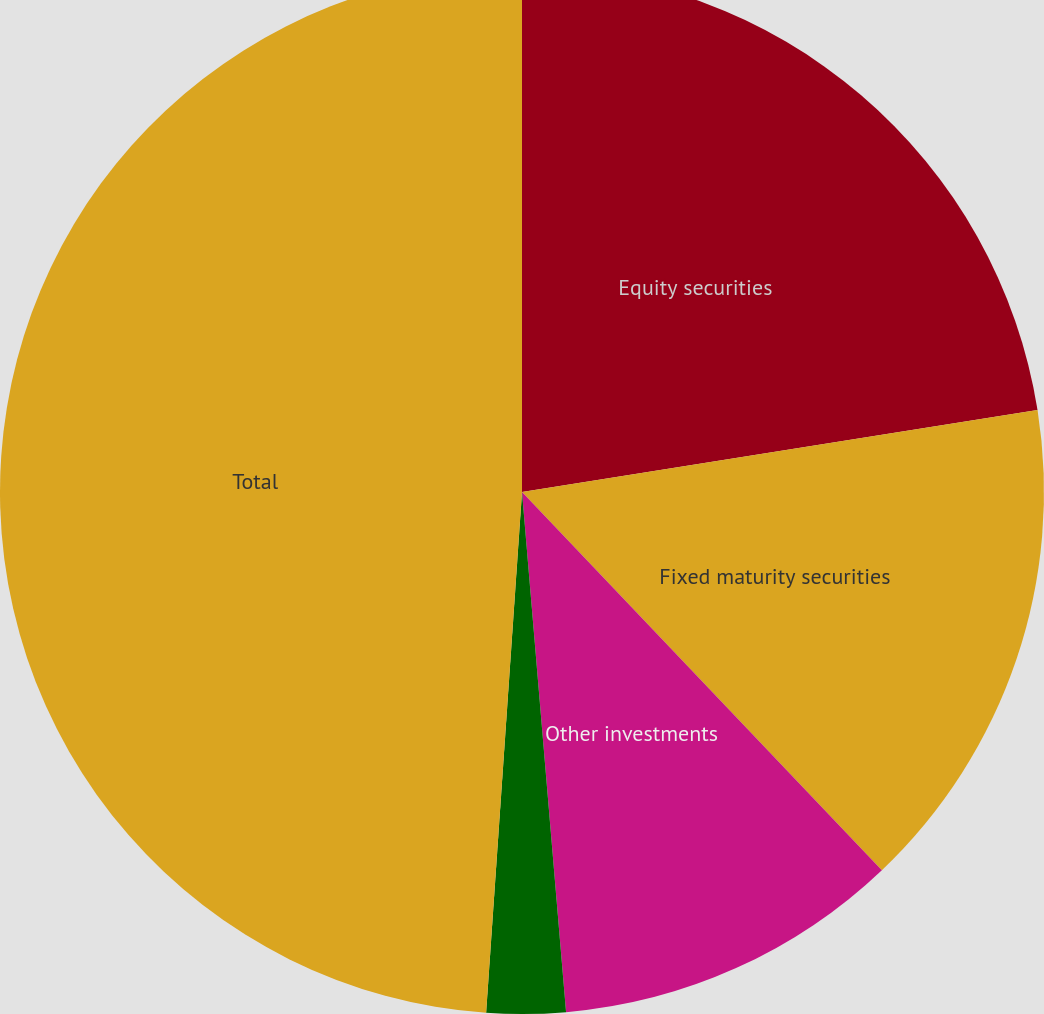<chart> <loc_0><loc_0><loc_500><loc_500><pie_chart><fcel>Equity securities<fcel>Fixed maturity securities<fcel>Other investments<fcel>Cash and cash equivalents<fcel>Total<nl><fcel>22.49%<fcel>15.4%<fcel>10.76%<fcel>2.44%<fcel>48.9%<nl></chart> 